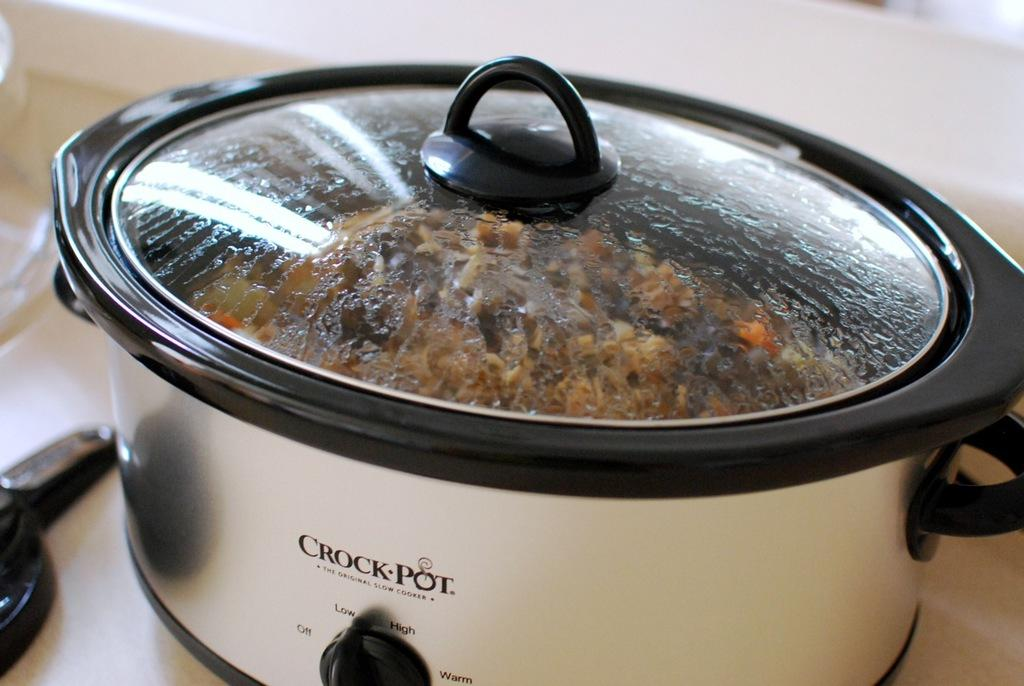<image>
Present a compact description of the photo's key features. Large white "Crockpot" cooking some dinner on a table. 